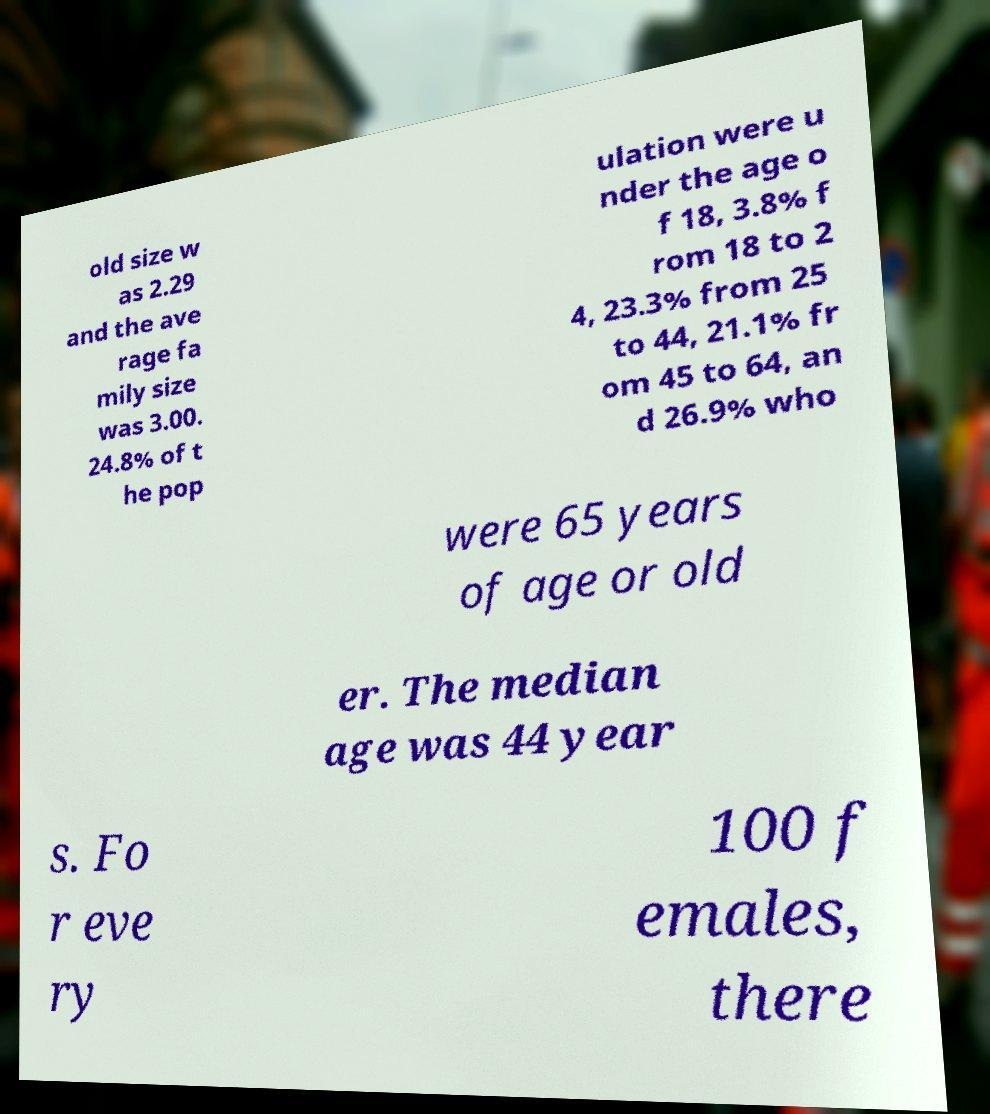I need the written content from this picture converted into text. Can you do that? old size w as 2.29 and the ave rage fa mily size was 3.00. 24.8% of t he pop ulation were u nder the age o f 18, 3.8% f rom 18 to 2 4, 23.3% from 25 to 44, 21.1% fr om 45 to 64, an d 26.9% who were 65 years of age or old er. The median age was 44 year s. Fo r eve ry 100 f emales, there 